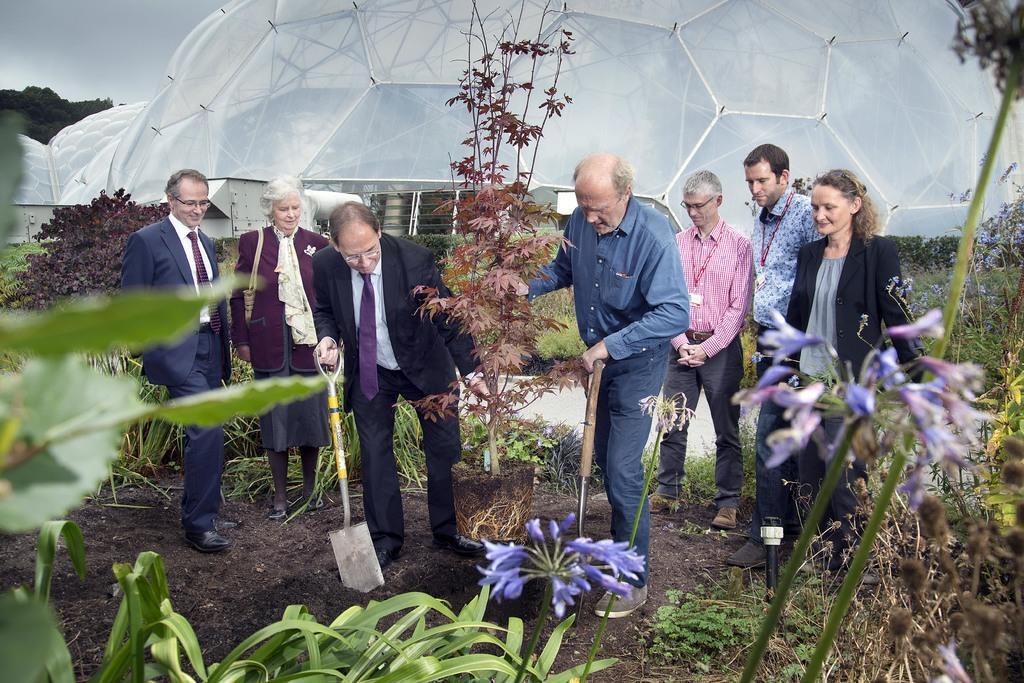Could you give a brief overview of what you see in this image? In this image there is the sky truncated towards the top of the image, there is an object truncated towards the top of the image, there are group of persons standing, there are persons holding an object, there are plants truncated towards the top of the image, there are plants truncated towards the right of the image, there are plants truncated towards the bottom of the image, there are plants truncated towards the left of the image, there are trees truncated towards the left of the image, there is soil. 